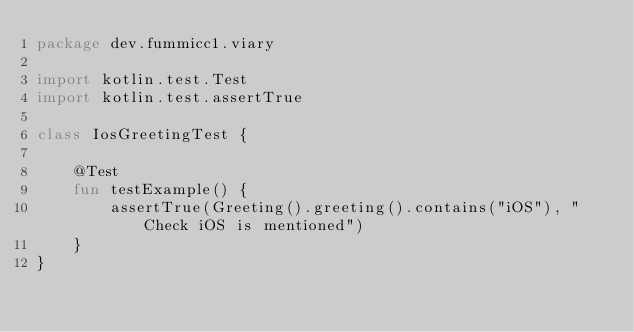<code> <loc_0><loc_0><loc_500><loc_500><_Kotlin_>package dev.fummicc1.viary

import kotlin.test.Test
import kotlin.test.assertTrue

class IosGreetingTest {

    @Test
    fun testExample() {
        assertTrue(Greeting().greeting().contains("iOS"), "Check iOS is mentioned")
    }
}</code> 